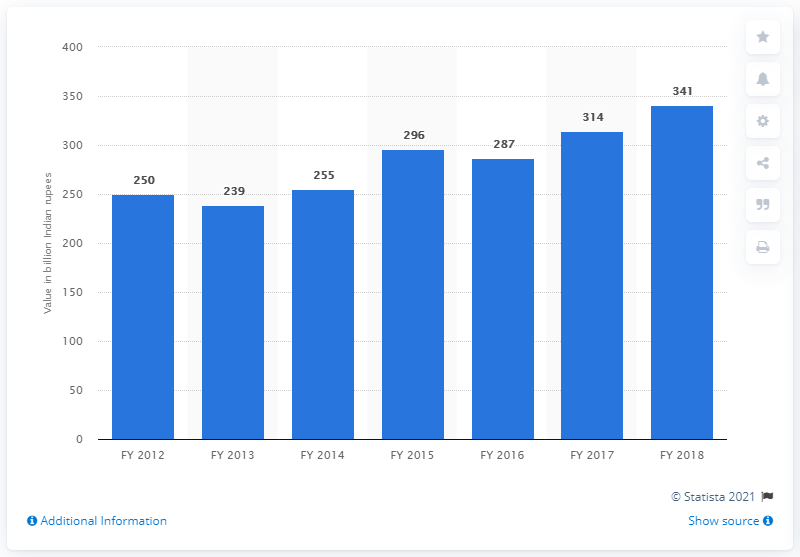Give some essential details in this illustration. In the fiscal year 2018, bananas contributed a significant amount of Indian rupees to the Indian economy. Specifically, bananas contributed 341 rupees to the economy. 